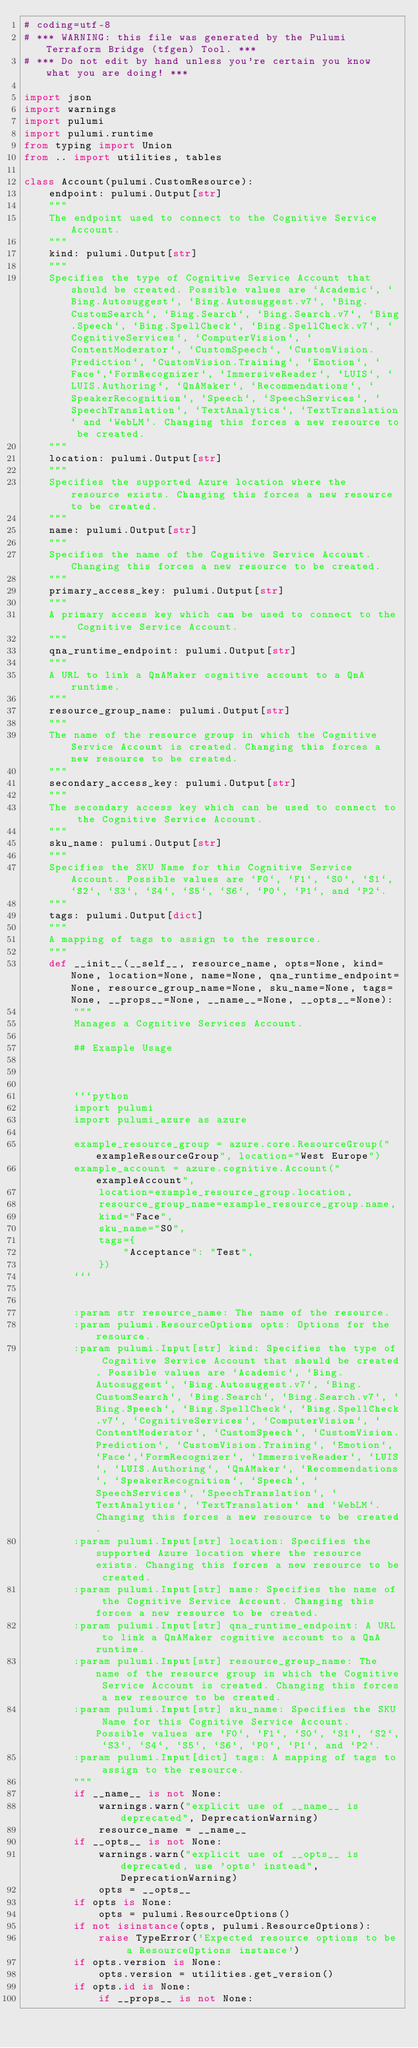Convert code to text. <code><loc_0><loc_0><loc_500><loc_500><_Python_># coding=utf-8
# *** WARNING: this file was generated by the Pulumi Terraform Bridge (tfgen) Tool. ***
# *** Do not edit by hand unless you're certain you know what you are doing! ***

import json
import warnings
import pulumi
import pulumi.runtime
from typing import Union
from .. import utilities, tables

class Account(pulumi.CustomResource):
    endpoint: pulumi.Output[str]
    """
    The endpoint used to connect to the Cognitive Service Account.
    """
    kind: pulumi.Output[str]
    """
    Specifies the type of Cognitive Service Account that should be created. Possible values are `Academic`, `Bing.Autosuggest`, `Bing.Autosuggest.v7`, `Bing.CustomSearch`, `Bing.Search`, `Bing.Search.v7`, `Bing.Speech`, `Bing.SpellCheck`, `Bing.SpellCheck.v7`, `CognitiveServices`, `ComputerVision`, `ContentModerator`, `CustomSpeech`, `CustomVision.Prediction`, `CustomVision.Training`, `Emotion`, `Face`,`FormRecognizer`, `ImmersiveReader`, `LUIS`, `LUIS.Authoring`, `QnAMaker`, `Recommendations`, `SpeakerRecognition`, `Speech`, `SpeechServices`, `SpeechTranslation`, `TextAnalytics`, `TextTranslation` and `WebLM`. Changing this forces a new resource to be created.
    """
    location: pulumi.Output[str]
    """
    Specifies the supported Azure location where the resource exists. Changing this forces a new resource to be created.
    """
    name: pulumi.Output[str]
    """
    Specifies the name of the Cognitive Service Account. Changing this forces a new resource to be created.
    """
    primary_access_key: pulumi.Output[str]
    """
    A primary access key which can be used to connect to the Cognitive Service Account.
    """
    qna_runtime_endpoint: pulumi.Output[str]
    """
    A URL to link a QnAMaker cognitive account to a QnA runtime.
    """
    resource_group_name: pulumi.Output[str]
    """
    The name of the resource group in which the Cognitive Service Account is created. Changing this forces a new resource to be created.
    """
    secondary_access_key: pulumi.Output[str]
    """
    The secondary access key which can be used to connect to the Cognitive Service Account.
    """
    sku_name: pulumi.Output[str]
    """
    Specifies the SKU Name for this Cognitive Service Account. Possible values are `F0`, `F1`, `S0`, `S1`, `S2`, `S3`, `S4`, `S5`, `S6`, `P0`, `P1`, and `P2`.
    """
    tags: pulumi.Output[dict]
    """
    A mapping of tags to assign to the resource.
    """
    def __init__(__self__, resource_name, opts=None, kind=None, location=None, name=None, qna_runtime_endpoint=None, resource_group_name=None, sku_name=None, tags=None, __props__=None, __name__=None, __opts__=None):
        """
        Manages a Cognitive Services Account.

        ## Example Usage



        ```python
        import pulumi
        import pulumi_azure as azure

        example_resource_group = azure.core.ResourceGroup("exampleResourceGroup", location="West Europe")
        example_account = azure.cognitive.Account("exampleAccount",
            location=example_resource_group.location,
            resource_group_name=example_resource_group.name,
            kind="Face",
            sku_name="S0",
            tags={
                "Acceptance": "Test",
            })
        ```


        :param str resource_name: The name of the resource.
        :param pulumi.ResourceOptions opts: Options for the resource.
        :param pulumi.Input[str] kind: Specifies the type of Cognitive Service Account that should be created. Possible values are `Academic`, `Bing.Autosuggest`, `Bing.Autosuggest.v7`, `Bing.CustomSearch`, `Bing.Search`, `Bing.Search.v7`, `Bing.Speech`, `Bing.SpellCheck`, `Bing.SpellCheck.v7`, `CognitiveServices`, `ComputerVision`, `ContentModerator`, `CustomSpeech`, `CustomVision.Prediction`, `CustomVision.Training`, `Emotion`, `Face`,`FormRecognizer`, `ImmersiveReader`, `LUIS`, `LUIS.Authoring`, `QnAMaker`, `Recommendations`, `SpeakerRecognition`, `Speech`, `SpeechServices`, `SpeechTranslation`, `TextAnalytics`, `TextTranslation` and `WebLM`. Changing this forces a new resource to be created.
        :param pulumi.Input[str] location: Specifies the supported Azure location where the resource exists. Changing this forces a new resource to be created.
        :param pulumi.Input[str] name: Specifies the name of the Cognitive Service Account. Changing this forces a new resource to be created.
        :param pulumi.Input[str] qna_runtime_endpoint: A URL to link a QnAMaker cognitive account to a QnA runtime.
        :param pulumi.Input[str] resource_group_name: The name of the resource group in which the Cognitive Service Account is created. Changing this forces a new resource to be created.
        :param pulumi.Input[str] sku_name: Specifies the SKU Name for this Cognitive Service Account. Possible values are `F0`, `F1`, `S0`, `S1`, `S2`, `S3`, `S4`, `S5`, `S6`, `P0`, `P1`, and `P2`.
        :param pulumi.Input[dict] tags: A mapping of tags to assign to the resource.
        """
        if __name__ is not None:
            warnings.warn("explicit use of __name__ is deprecated", DeprecationWarning)
            resource_name = __name__
        if __opts__ is not None:
            warnings.warn("explicit use of __opts__ is deprecated, use 'opts' instead", DeprecationWarning)
            opts = __opts__
        if opts is None:
            opts = pulumi.ResourceOptions()
        if not isinstance(opts, pulumi.ResourceOptions):
            raise TypeError('Expected resource options to be a ResourceOptions instance')
        if opts.version is None:
            opts.version = utilities.get_version()
        if opts.id is None:
            if __props__ is not None:</code> 